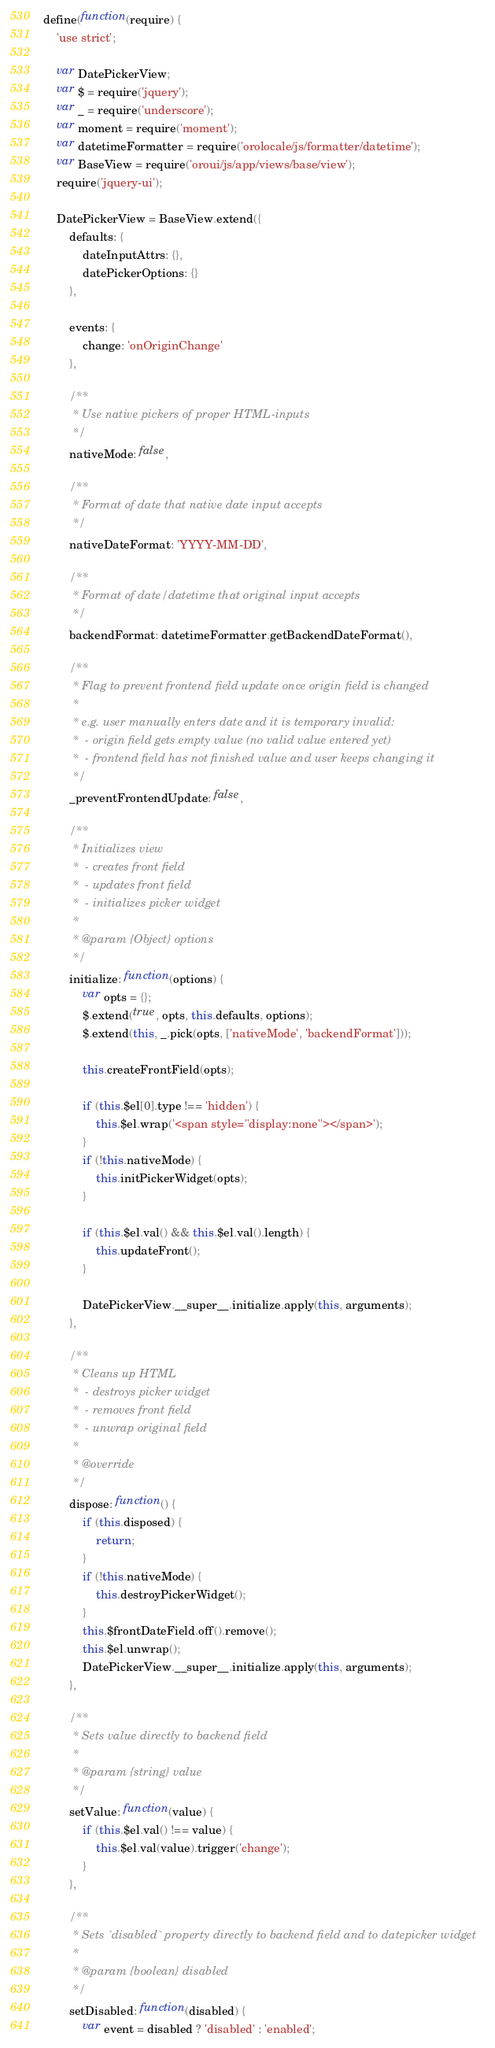Convert code to text. <code><loc_0><loc_0><loc_500><loc_500><_JavaScript_>define(function(require) {
    'use strict';

    var DatePickerView;
    var $ = require('jquery');
    var _ = require('underscore');
    var moment = require('moment');
    var datetimeFormatter = require('orolocale/js/formatter/datetime');
    var BaseView = require('oroui/js/app/views/base/view');
    require('jquery-ui');

    DatePickerView = BaseView.extend({
        defaults: {
            dateInputAttrs: {},
            datePickerOptions: {}
        },

        events: {
            change: 'onOriginChange'
        },

        /**
         * Use native pickers of proper HTML-inputs
         */
        nativeMode: false,

        /**
         * Format of date that native date input accepts
         */
        nativeDateFormat: 'YYYY-MM-DD',

        /**
         * Format of date/datetime that original input accepts
         */
        backendFormat: datetimeFormatter.getBackendDateFormat(),

        /**
         * Flag to prevent frontend field update once origin field is changed
         *
         * e.g. user manually enters date and it is temporary invalid:
         *  - origin field gets empty value (no valid value entered yet)
         *  - frontend field has not finished value and user keeps changing it
         */
        _preventFrontendUpdate: false,

        /**
         * Initializes view
         *  - creates front field
         *  - updates front field
         *  - initializes picker widget
         *
         * @param {Object} options
         */
        initialize: function(options) {
            var opts = {};
            $.extend(true, opts, this.defaults, options);
            $.extend(this, _.pick(opts, ['nativeMode', 'backendFormat']));

            this.createFrontField(opts);

            if (this.$el[0].type !== 'hidden') {
                this.$el.wrap('<span style="display:none"></span>');
            }
            if (!this.nativeMode) {
                this.initPickerWidget(opts);
            }

            if (this.$el.val() && this.$el.val().length) {
                this.updateFront();
            }

            DatePickerView.__super__.initialize.apply(this, arguments);
        },

        /**
         * Cleans up HTML
         *  - destroys picker widget
         *  - removes front field
         *  - unwrap original field
         *
         * @override
         */
        dispose: function() {
            if (this.disposed) {
                return;
            }
            if (!this.nativeMode) {
                this.destroyPickerWidget();
            }
            this.$frontDateField.off().remove();
            this.$el.unwrap();
            DatePickerView.__super__.initialize.apply(this, arguments);
        },

        /**
         * Sets value directly to backend field
         *
         * @param {string} value
         */
        setValue: function(value) {
            if (this.$el.val() !== value) {
                this.$el.val(value).trigger('change');
            }
        },

        /**
         * Sets `disabled` property directly to backend field and to datepicker widget
         *
         * @param {boolean} disabled
         */
        setDisabled: function(disabled) {
            var event = disabled ? 'disabled' : 'enabled';</code> 